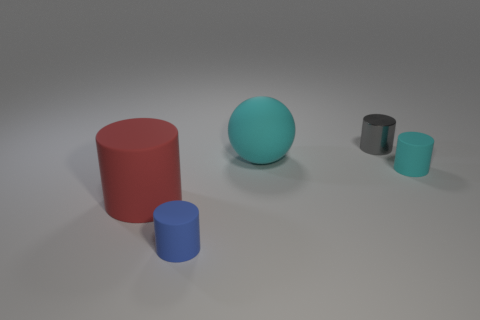Is the number of small matte cylinders that are to the right of the matte sphere greater than the number of big cyan things that are on the left side of the red matte object?
Offer a terse response. Yes. How many other things are the same size as the gray metal cylinder?
Provide a succinct answer. 2. The cylinder that is to the right of the large red rubber cylinder and to the left of the small gray thing is made of what material?
Ensure brevity in your answer.  Rubber. There is a tiny gray object that is the same shape as the red thing; what is it made of?
Your response must be concise. Metal. How many small cylinders are in front of the tiny object that is behind the big thing that is to the right of the blue matte object?
Give a very brief answer. 2. Is there anything else that is the same color as the matte sphere?
Ensure brevity in your answer.  Yes. What number of cyan rubber things are right of the small gray metal cylinder and left of the tiny cyan matte cylinder?
Offer a terse response. 0. There is a cylinder behind the matte ball; is it the same size as the matte cylinder in front of the big red matte object?
Offer a terse response. Yes. How many things are either matte objects that are on the left side of the small gray object or large gray shiny blocks?
Offer a terse response. 3. What is the tiny gray thing that is behind the large red cylinder made of?
Keep it short and to the point. Metal. 